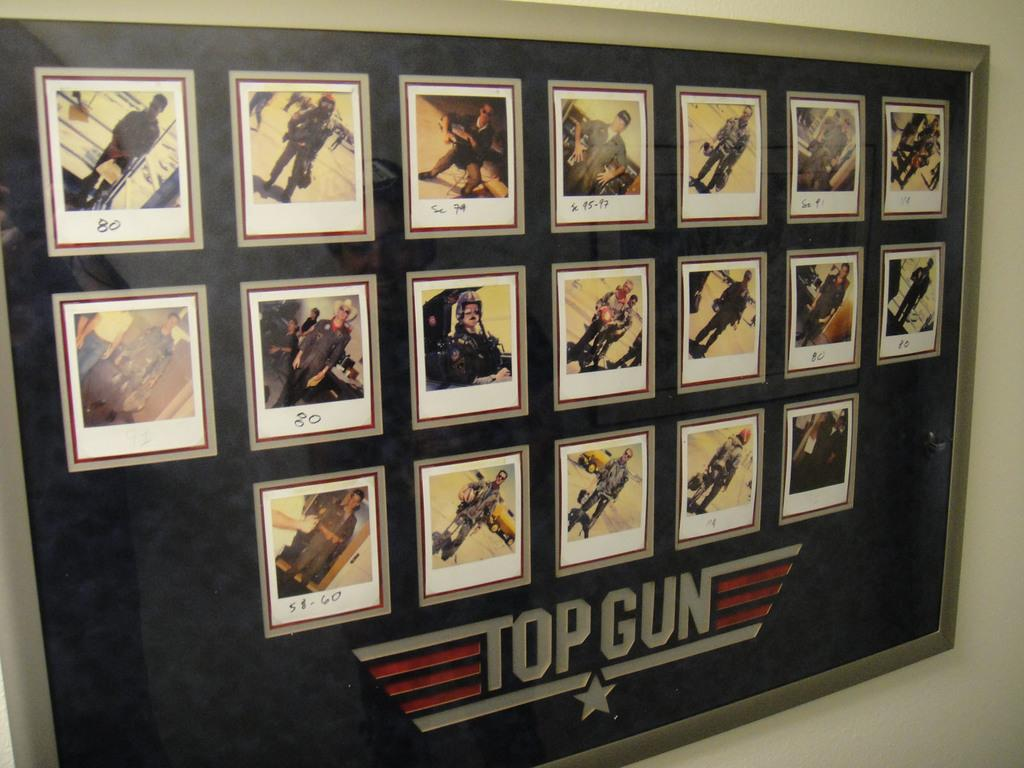<image>
Provide a brief description of the given image. Various pictures are displayed in a frame with the label "Top Gun". 